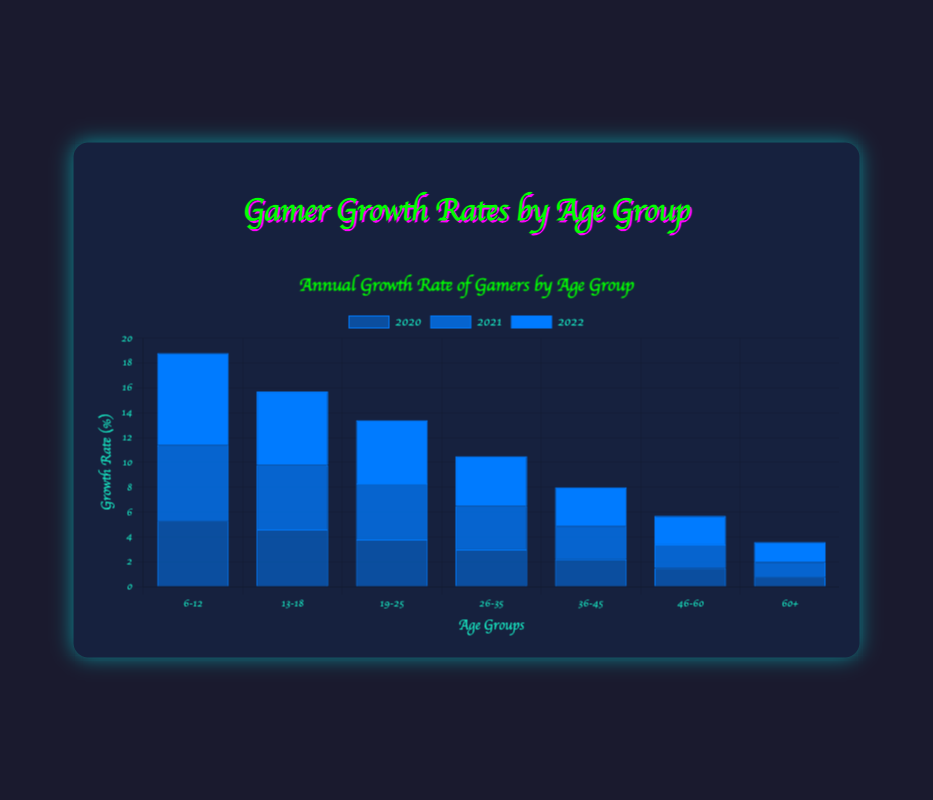Which age group had the highest growth rate in 2022? To find the highest growth rate in 2022, look at the bars labeled "2022" for each age group and compare their heights. The "6-12" age group has the tallest bar in 2022.
Answer: 6-12 What is the total growth rate percentage for the "13-18" age group from 2020 to 2022? Sum up the growth rate percentages for the "13-18" age group across the years 2020, 2021, and 2022. The values are 4.6, 5.2, and 5.9 respectively. 4.6 + 5.2 + 5.9 = 15.7%.
Answer: 15.7% Which year saw the highest growth rate for the "26-35" age group? Compare the heights of the bars labeled "26-35" across 2020, 2021, and 2022. The tallest bar for the "26-35" age group is for the year 2022.
Answer: 2022 How does the growth rate for the "19-25" age group in 2020 compare to the "46-60" age group in 2022? Refer to the height of the bars for the "19-25" age group in 2020 and "46-60" age group in 2022. The figures are 3.8% and 2.3% respectively. 3.8% is greater than 2.3%.
Answer: "19-25" in 2020 is higher Which age group showed the lowest growth rate in 2020? Compare the heights of the bars for different age groups in 2020. The "60+" age group has the shortest bar, indicating the lowest growth rate.
Answer: 60+ What was the average growth rate of gamers aged "36-45" from 2020 to 2022? To find the average, sum the growth rates for 2020, 2021, and 2022 then divide by 3. The values are 2.2, 2.7, and 3.1. (2.2 + 2.7 + 3.1) / 3 = 8/3 ≈ 2.67%.
Answer: 2.67% Did the growth rate for the "60+" age group increase or decrease from 2021 to 2022? Compare the height of the bars for the "60+" age group in 2021 and 2022. The values are 1.2% in 2021 and 1.6% in 2022. The growth rate increased.
Answer: Increased What is the difference in growth rates between the "6-12" age group and the "26-35" age group in 2022? Subtract the growth rate percentage of the "26-35" age group from the "6-12" age group in 2022. The values are 7.4% and 4.0% respectively. 7.4 - 4.0 = 3.4%.
Answer: 3.4% What's the combined growth rate percentage for "19-25" and "36-45" age groups in 2021? Add the growth rates for "19-25" and "36-45" age groups in 2021. The values are 4.5% and 2.7% respectively. 4.5 + 2.7 = 7.2%.
Answer: 7.2% 